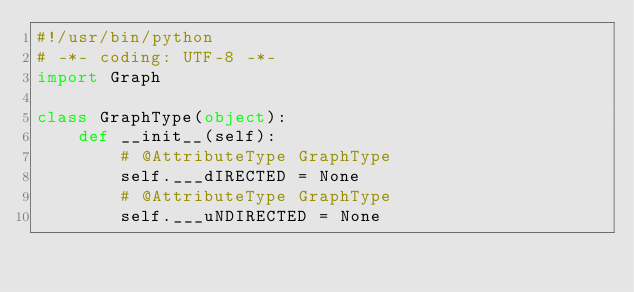Convert code to text. <code><loc_0><loc_0><loc_500><loc_500><_Python_>#!/usr/bin/python
# -*- coding: UTF-8 -*-
import Graph

class GraphType(object):
	def __init__(self):
		# @AttributeType GraphType
		self.___dIRECTED = None
		# @AttributeType GraphType
		self.___uNDIRECTED = None


</code> 